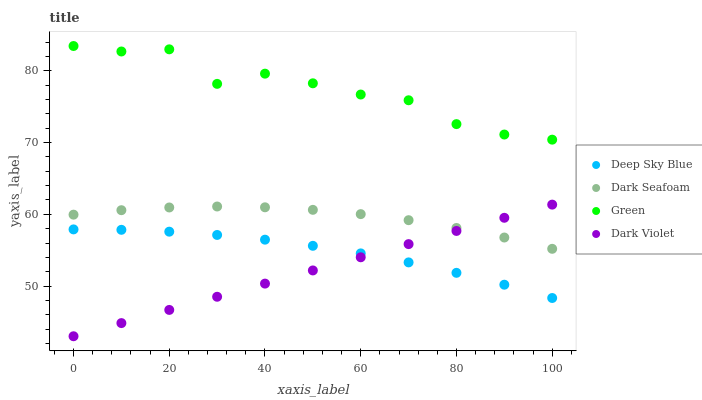Does Dark Violet have the minimum area under the curve?
Answer yes or no. Yes. Does Green have the maximum area under the curve?
Answer yes or no. Yes. Does Green have the minimum area under the curve?
Answer yes or no. No. Does Dark Violet have the maximum area under the curve?
Answer yes or no. No. Is Dark Violet the smoothest?
Answer yes or no. Yes. Is Green the roughest?
Answer yes or no. Yes. Is Green the smoothest?
Answer yes or no. No. Is Dark Violet the roughest?
Answer yes or no. No. Does Dark Violet have the lowest value?
Answer yes or no. Yes. Does Green have the lowest value?
Answer yes or no. No. Does Green have the highest value?
Answer yes or no. Yes. Does Dark Violet have the highest value?
Answer yes or no. No. Is Dark Violet less than Green?
Answer yes or no. Yes. Is Green greater than Dark Violet?
Answer yes or no. Yes. Does Deep Sky Blue intersect Dark Violet?
Answer yes or no. Yes. Is Deep Sky Blue less than Dark Violet?
Answer yes or no. No. Is Deep Sky Blue greater than Dark Violet?
Answer yes or no. No. Does Dark Violet intersect Green?
Answer yes or no. No. 